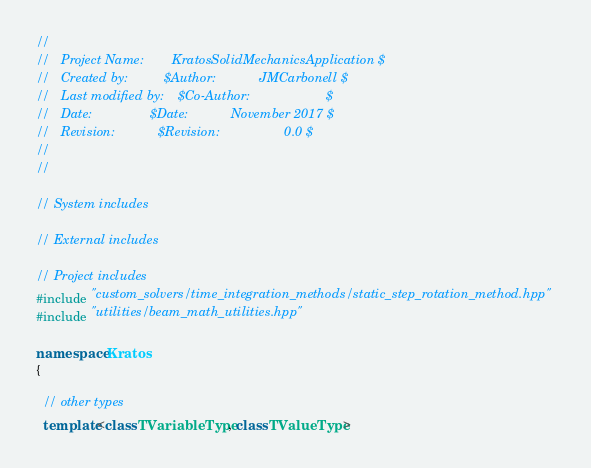<code> <loc_0><loc_0><loc_500><loc_500><_C++_>//
//   Project Name:        KratosSolidMechanicsApplication $
//   Created by:          $Author:            JMCarbonell $
//   Last modified by:    $Co-Author:                     $
//   Date:                $Date:            November 2017 $
//   Revision:            $Revision:                  0.0 $
//
//

// System includes

// External includes

// Project includes
#include "custom_solvers/time_integration_methods/static_step_rotation_method.hpp"
#include "utilities/beam_math_utilities.hpp"

namespace Kratos
{

  // other types
  template<class TVariableType, class TValueType></code> 